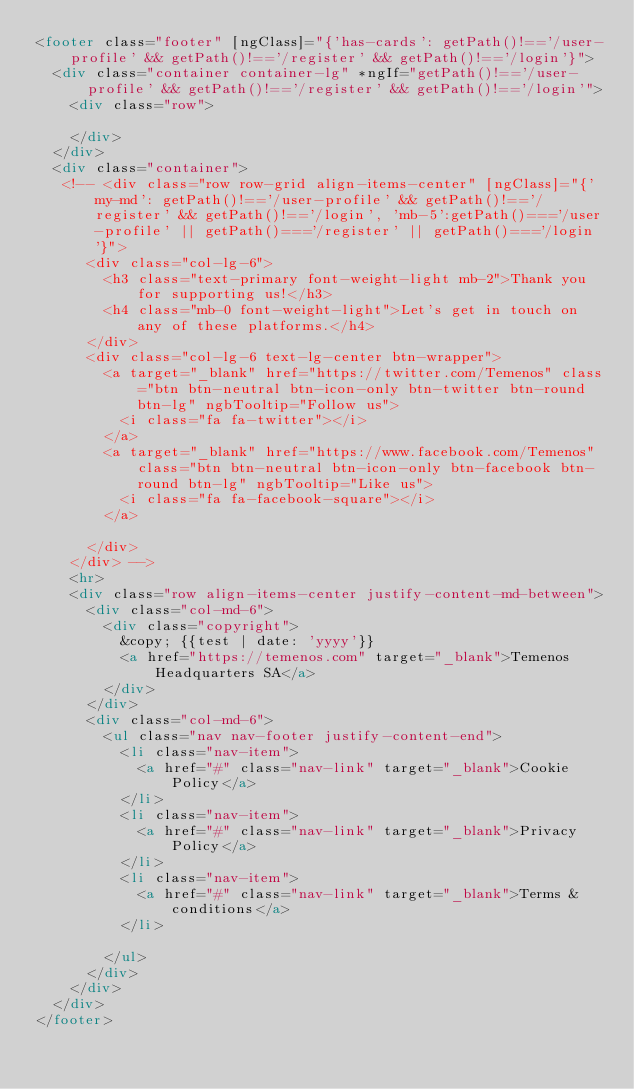Convert code to text. <code><loc_0><loc_0><loc_500><loc_500><_HTML_><footer class="footer" [ngClass]="{'has-cards': getPath()!=='/user-profile' && getPath()!=='/register' && getPath()!=='/login'}">
  <div class="container container-lg" *ngIf="getPath()!=='/user-profile' && getPath()!=='/register' && getPath()!=='/login'">
    <div class="row">
     
    </div>
  </div>
  <div class="container">
   <!-- <div class="row row-grid align-items-center" [ngClass]="{'my-md': getPath()!=='/user-profile' && getPath()!=='/register' && getPath()!=='/login', 'mb-5':getPath()==='/user-profile' || getPath()==='/register' || getPath()==='/login'}">
      <div class="col-lg-6">
        <h3 class="text-primary font-weight-light mb-2">Thank you for supporting us!</h3>
        <h4 class="mb-0 font-weight-light">Let's get in touch on any of these platforms.</h4>
      </div>
      <div class="col-lg-6 text-lg-center btn-wrapper">
        <a target="_blank" href="https://twitter.com/Temenos" class="btn btn-neutral btn-icon-only btn-twitter btn-round btn-lg" ngbTooltip="Follow us">
          <i class="fa fa-twitter"></i>
        </a>
        <a target="_blank" href="https://www.facebook.com/Temenos" class="btn btn-neutral btn-icon-only btn-facebook btn-round btn-lg" ngbTooltip="Like us">
          <i class="fa fa-facebook-square"></i>
        </a>
 
      </div>
    </div> -->
    <hr>
    <div class="row align-items-center justify-content-md-between">
      <div class="col-md-6">
        <div class="copyright">
          &copy; {{test | date: 'yyyy'}}
          <a href="https://temenos.com" target="_blank">Temenos Headquarters SA</a>
        </div>
      </div>
      <div class="col-md-6">
        <ul class="nav nav-footer justify-content-end">
          <li class="nav-item">
            <a href="#" class="nav-link" target="_blank">Cookie Policy</a>
          </li>
          <li class="nav-item">
            <a href="#" class="nav-link" target="_blank">Privacy Policy</a>
          </li>
          <li class="nav-item">
            <a href="#" class="nav-link" target="_blank">Terms & conditions</a>
          </li>
   
        </ul>
      </div>
    </div>
  </div>
</footer>
</code> 